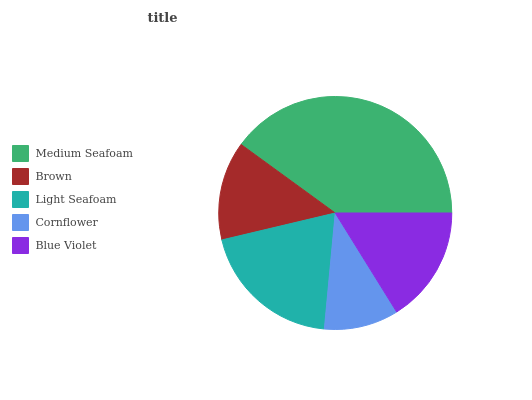Is Cornflower the minimum?
Answer yes or no. Yes. Is Medium Seafoam the maximum?
Answer yes or no. Yes. Is Brown the minimum?
Answer yes or no. No. Is Brown the maximum?
Answer yes or no. No. Is Medium Seafoam greater than Brown?
Answer yes or no. Yes. Is Brown less than Medium Seafoam?
Answer yes or no. Yes. Is Brown greater than Medium Seafoam?
Answer yes or no. No. Is Medium Seafoam less than Brown?
Answer yes or no. No. Is Blue Violet the high median?
Answer yes or no. Yes. Is Blue Violet the low median?
Answer yes or no. Yes. Is Light Seafoam the high median?
Answer yes or no. No. Is Brown the low median?
Answer yes or no. No. 